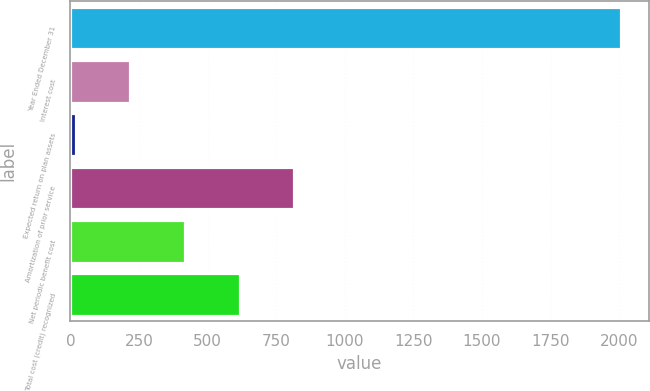<chart> <loc_0><loc_0><loc_500><loc_500><bar_chart><fcel>Year Ended December 31<fcel>Interest cost<fcel>Expected return on plan assets<fcel>Amortization of prior service<fcel>Net periodic benefit cost<fcel>Total cost (credit) recognized<nl><fcel>2008<fcel>218.8<fcel>20<fcel>815.2<fcel>417.6<fcel>616.4<nl></chart> 